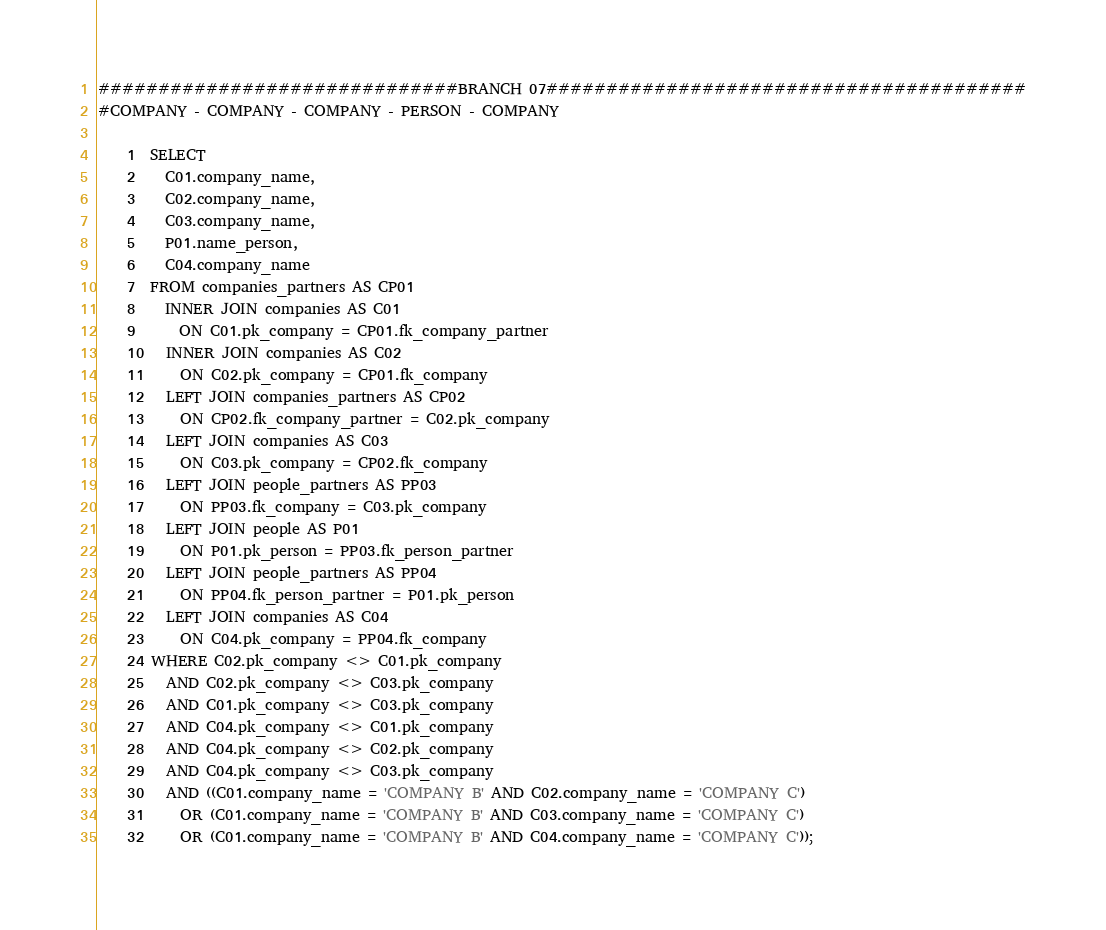Convert code to text. <code><loc_0><loc_0><loc_500><loc_500><_SQL_>##############################BRANCH 07########################################
#COMPANY - COMPANY - COMPANY - PERSON - COMPANY
	
	1  SELECT 
	2    C01.company_name, 
	3    C02.company_name,
	4    C03.company_name,
	5    P01.name_person,
	6    C04.company_name
	7  FROM companies_partners AS CP01
	8    INNER JOIN companies AS C01 
	9      ON C01.pk_company = CP01.fk_company_partner
	10   INNER JOIN companies AS C02 
	11     ON C02.pk_company = CP01.fk_company    
	12   LEFT JOIN companies_partners AS CP02 
	13     ON CP02.fk_company_partner = C02.pk_company
	14   LEFT JOIN companies AS C03 
	15     ON C03.pk_company = CP02.fk_company
	16   LEFT JOIN people_partners AS PP03
	17     ON PP03.fk_company = C03.pk_company
	18   LEFT JOIN people AS P01
	19     ON P01.pk_person = PP03.fk_person_partner
	20   LEFT JOIN people_partners AS PP04 
	21     ON PP04.fk_person_partner = P01.pk_person
	22   LEFT JOIN companies AS C04 
	23     ON C04.pk_company = PP04.fk_company
	24 WHERE C02.pk_company <> C01.pk_company 
	25   AND C02.pk_company <> C03.pk_company 
	26   AND C01.pk_company <> C03.pk_company
	27   AND C04.pk_company <> C01.pk_company
	28   AND C04.pk_company <> C02.pk_company
	29   AND C04.pk_company <> C03.pk_company
	30   AND ((C01.company_name = 'COMPANY B' AND C02.company_name = 'COMPANY C') 
	31     OR (C01.company_name = 'COMPANY B' AND C03.company_name = 'COMPANY C') 
	32     OR (C01.company_name = 'COMPANY B' AND C04.company_name = 'COMPANY C'));
</code> 